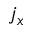<formula> <loc_0><loc_0><loc_500><loc_500>j _ { x }</formula> 